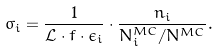Convert formula to latex. <formula><loc_0><loc_0><loc_500><loc_500>\bar { \sigma _ { i } } = \frac { 1 } { \mathcal { L } \cdot f \cdot \epsilon _ { i } } \cdot \frac { n _ { i } } { N _ { i } ^ { M C } / N ^ { M C } } .</formula> 